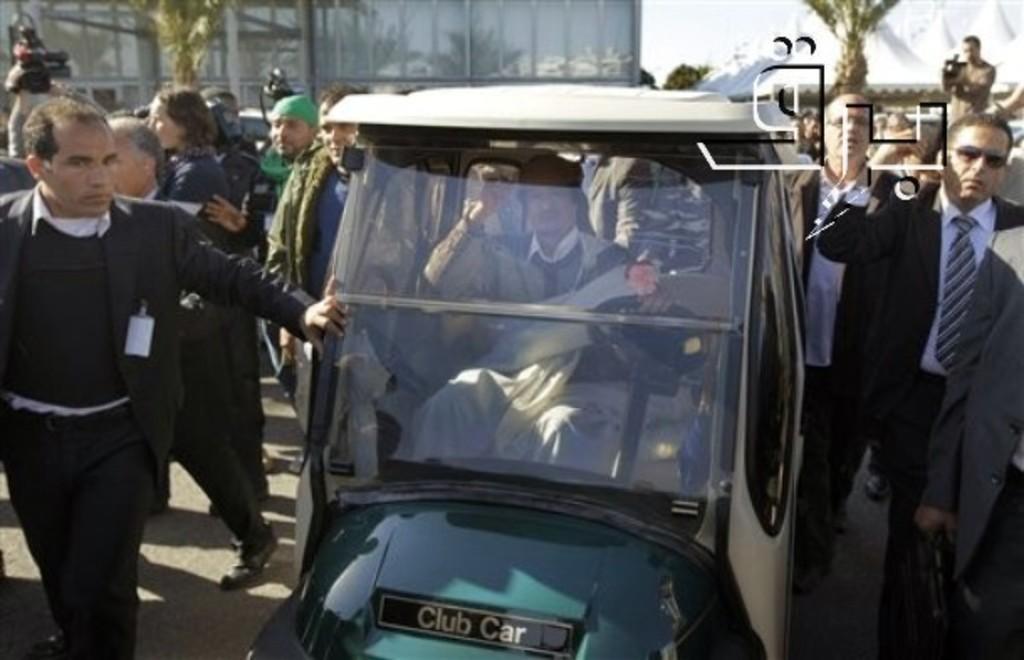How would you summarize this image in a sentence or two? Far there is a building and trees. Persons are standing. A person is sitting inside this vehicle. This person is holding a camera. 